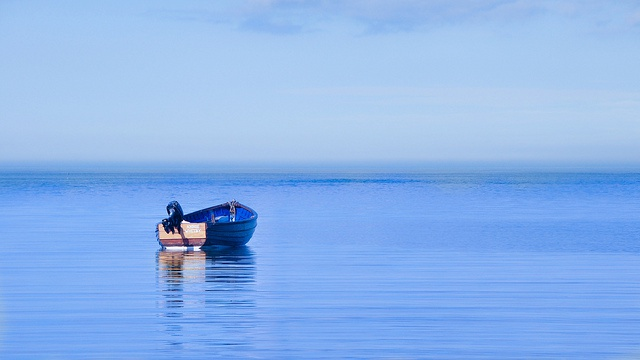Describe the objects in this image and their specific colors. I can see a boat in lightblue, navy, blue, and darkblue tones in this image. 